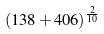Convert formula to latex. <formula><loc_0><loc_0><loc_500><loc_500>( 1 3 8 + 4 0 6 ) ^ { \frac { 2 } { 1 0 } }</formula> 